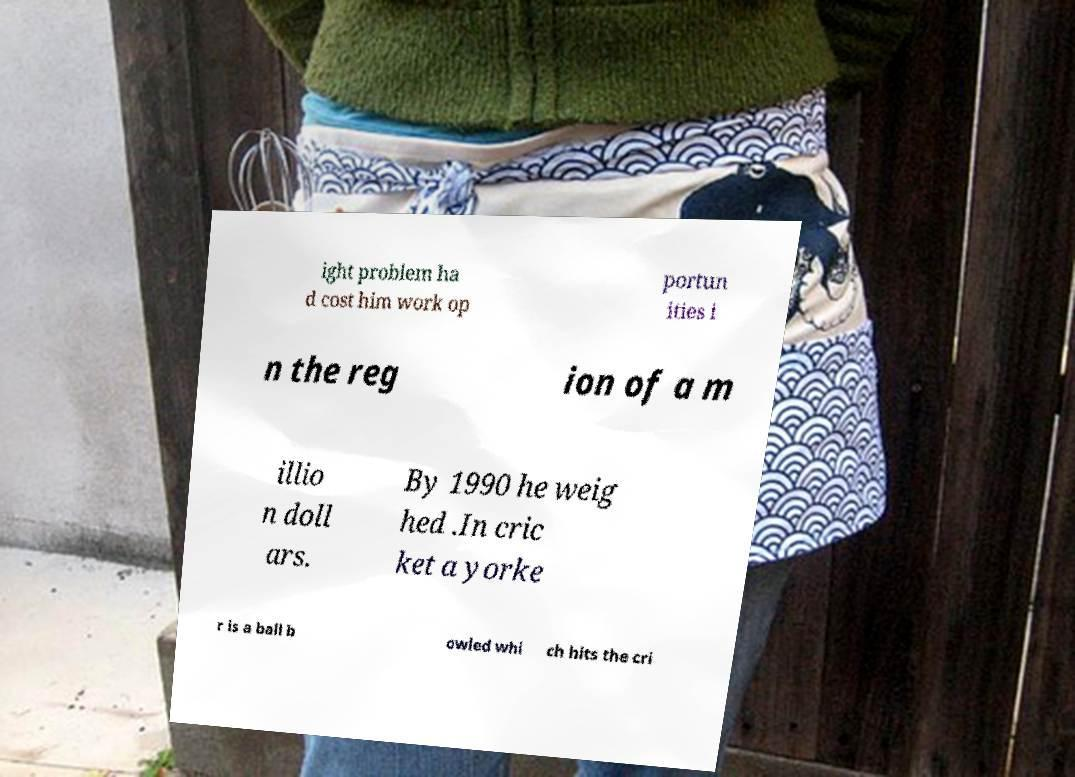Could you extract and type out the text from this image? ight problem ha d cost him work op portun ities i n the reg ion of a m illio n doll ars. By 1990 he weig hed .In cric ket a yorke r is a ball b owled whi ch hits the cri 